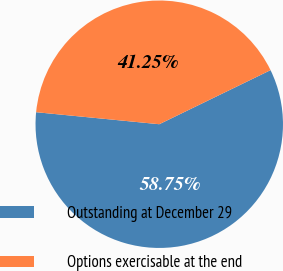<chart> <loc_0><loc_0><loc_500><loc_500><pie_chart><fcel>Outstanding at December 29<fcel>Options exercisable at the end<nl><fcel>58.75%<fcel>41.25%<nl></chart> 